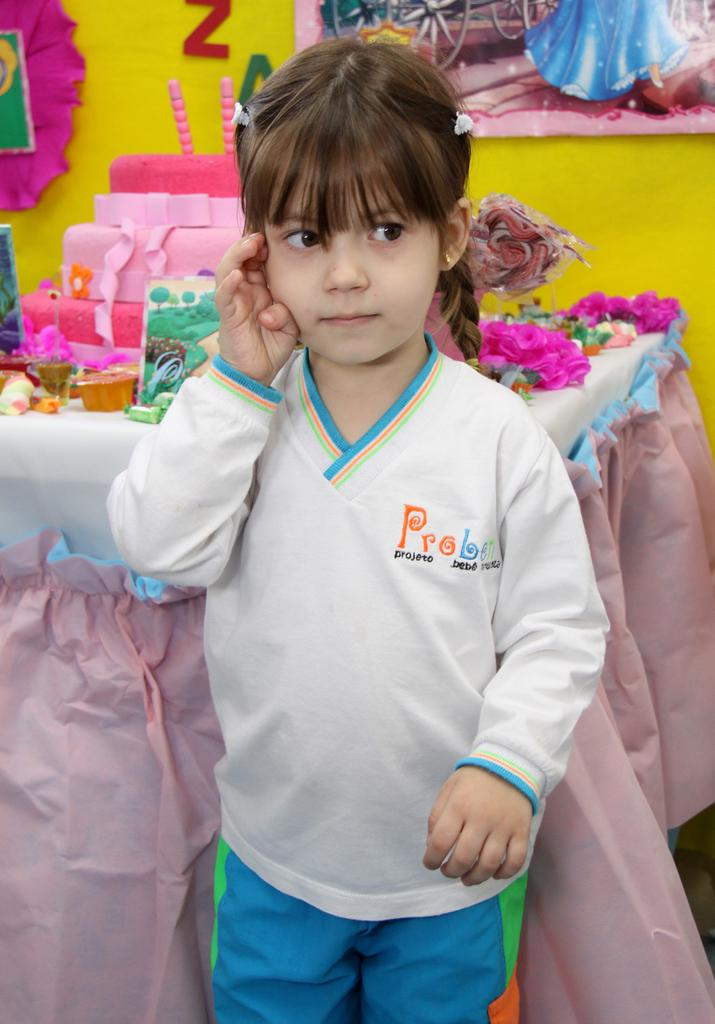What is the main subject of the image? The main subject of the image is a kid standing. What can be seen in the background of the image? There is a table in the image. What is on the table? There are objects placed on the table. What color is the wall in the image? The wall in the image is yellow. What type of copper grip can be seen on the kid's hand in the image? There is no copper grip or any grip visible on the kid's hand in the image. 